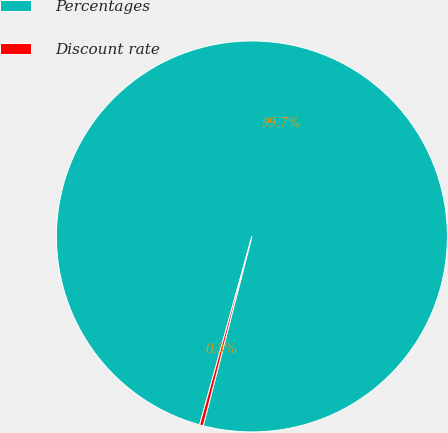Convert chart. <chart><loc_0><loc_0><loc_500><loc_500><pie_chart><fcel>Percentages<fcel>Discount rate<nl><fcel>99.7%<fcel>0.3%<nl></chart> 